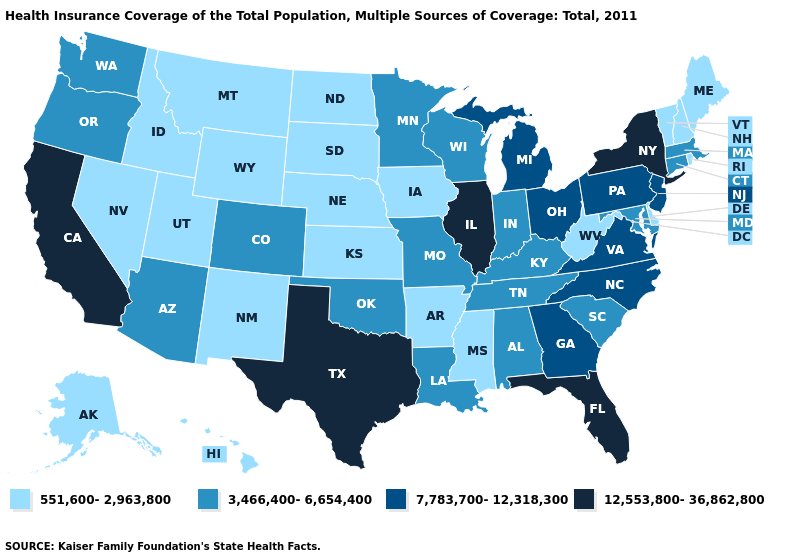Name the states that have a value in the range 12,553,800-36,862,800?
Concise answer only. California, Florida, Illinois, New York, Texas. Does Oklahoma have the highest value in the USA?
Give a very brief answer. No. What is the value of California?
Short answer required. 12,553,800-36,862,800. Among the states that border Nevada , which have the highest value?
Concise answer only. California. What is the value of West Virginia?
Short answer required. 551,600-2,963,800. Among the states that border Indiana , does Michigan have the lowest value?
Answer briefly. No. Among the states that border New York , does Vermont have the lowest value?
Short answer required. Yes. Among the states that border Maine , which have the lowest value?
Short answer required. New Hampshire. Among the states that border Virginia , does North Carolina have the highest value?
Keep it brief. Yes. What is the value of Washington?
Be succinct. 3,466,400-6,654,400. Name the states that have a value in the range 551,600-2,963,800?
Write a very short answer. Alaska, Arkansas, Delaware, Hawaii, Idaho, Iowa, Kansas, Maine, Mississippi, Montana, Nebraska, Nevada, New Hampshire, New Mexico, North Dakota, Rhode Island, South Dakota, Utah, Vermont, West Virginia, Wyoming. Does Oregon have the lowest value in the West?
Short answer required. No. What is the value of South Dakota?
Write a very short answer. 551,600-2,963,800. What is the highest value in the USA?
Concise answer only. 12,553,800-36,862,800. Name the states that have a value in the range 551,600-2,963,800?
Quick response, please. Alaska, Arkansas, Delaware, Hawaii, Idaho, Iowa, Kansas, Maine, Mississippi, Montana, Nebraska, Nevada, New Hampshire, New Mexico, North Dakota, Rhode Island, South Dakota, Utah, Vermont, West Virginia, Wyoming. 